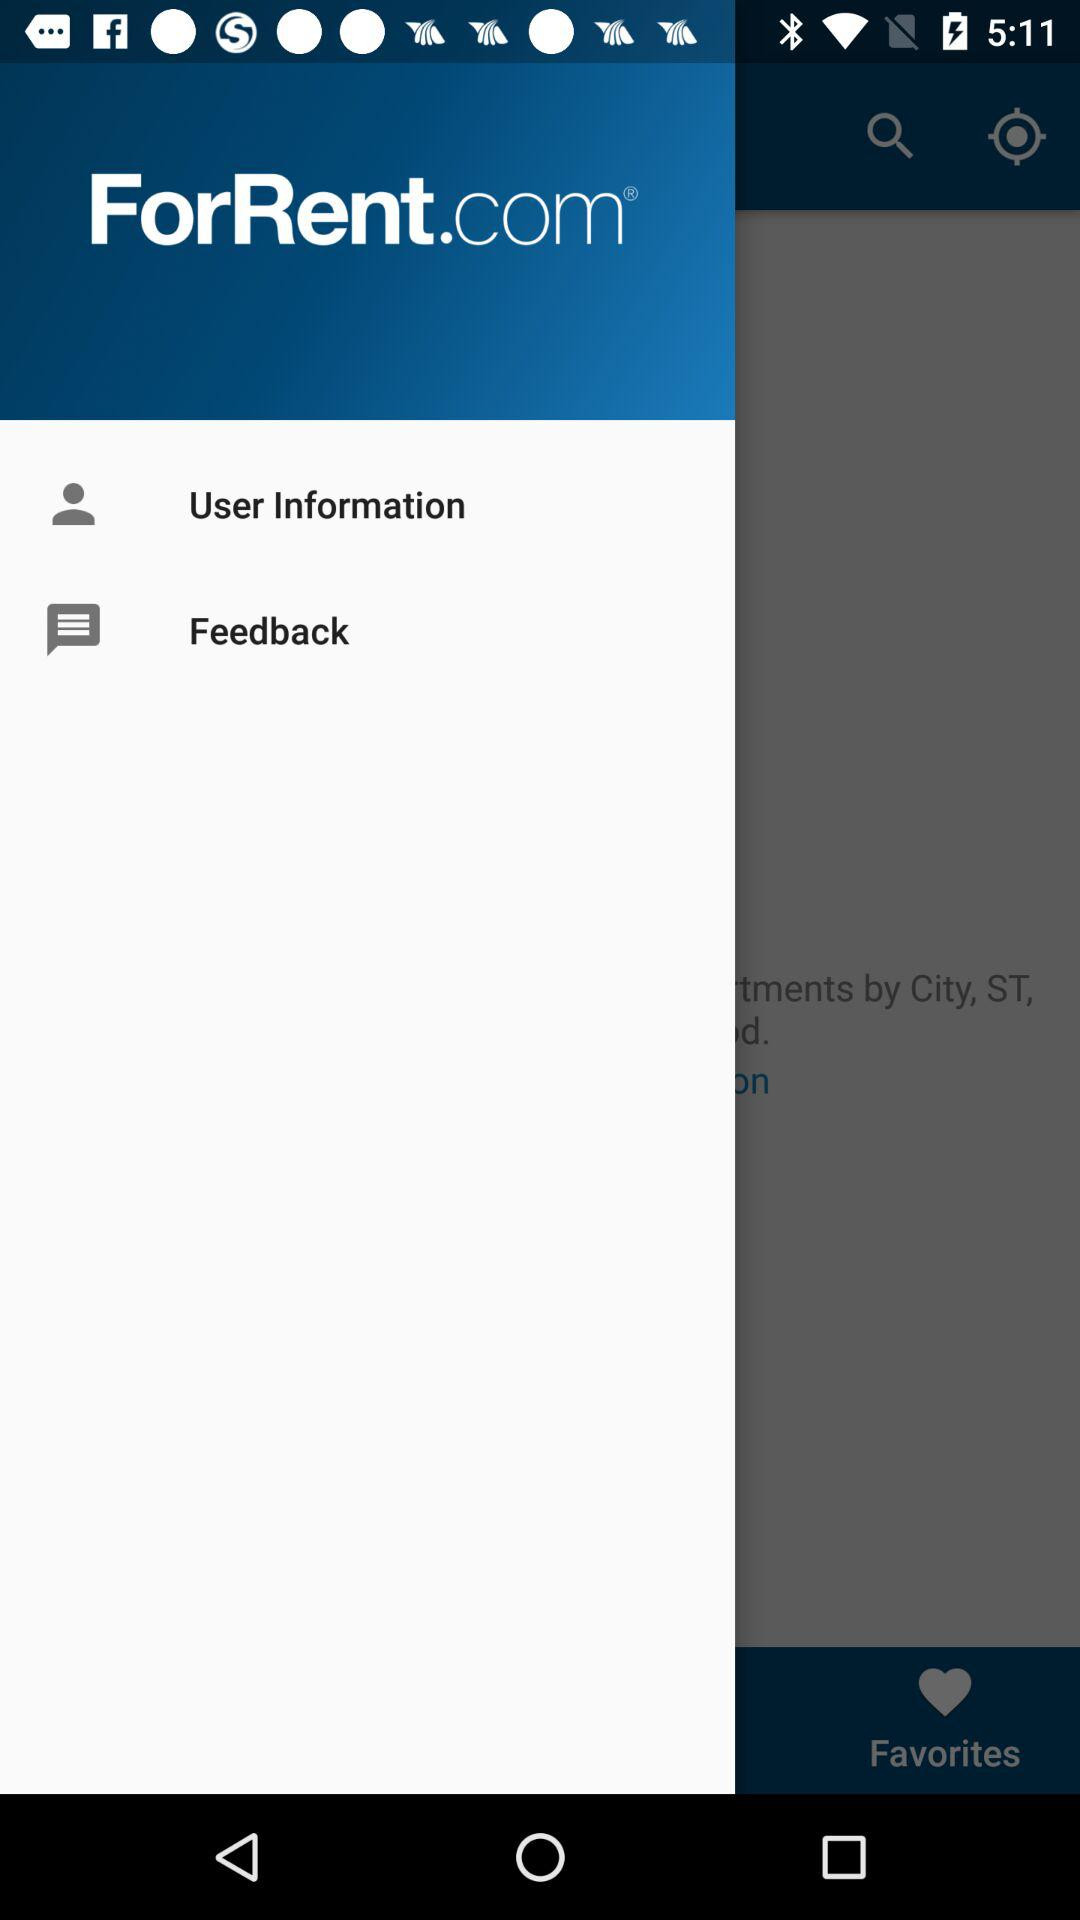What is the app name? The app name is "ForRent.com". 